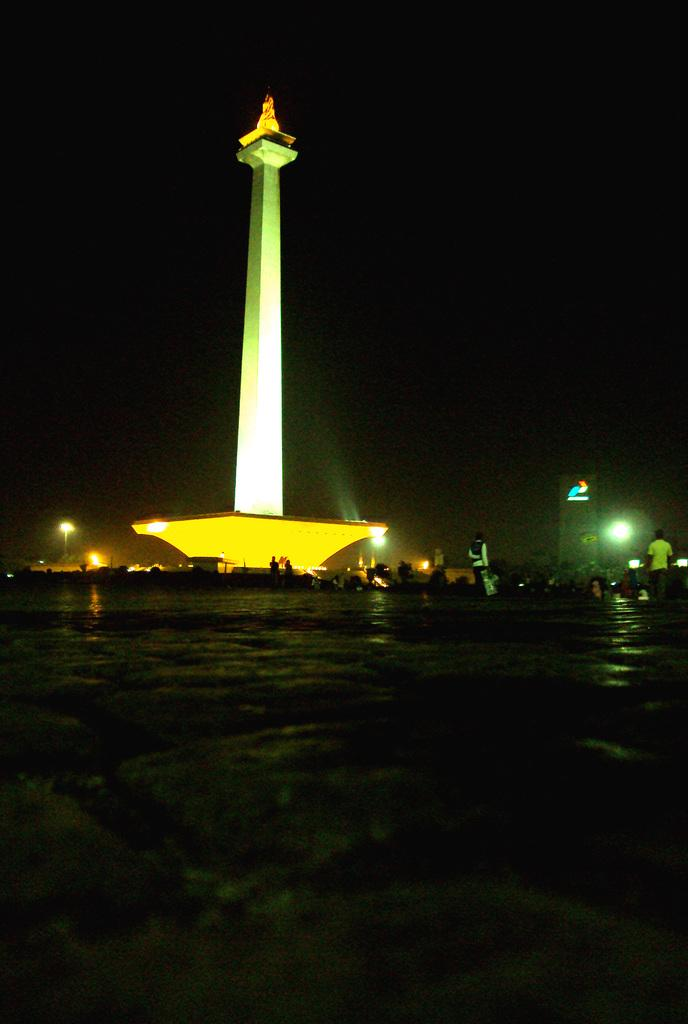What is the main structure in the middle of the image? There is a huge pillar in the middle of the image. What is surrounding the pillar? There are lights around the pillar. What is in front of the pillar? There is a lake in front of the pillar. When was the image taken? The image was taken at night time. What type of window can be seen in the image? There is no window present in the image. What experience can be gained from visiting the location in the image? The image does not provide information about the experience one might have at the location. 